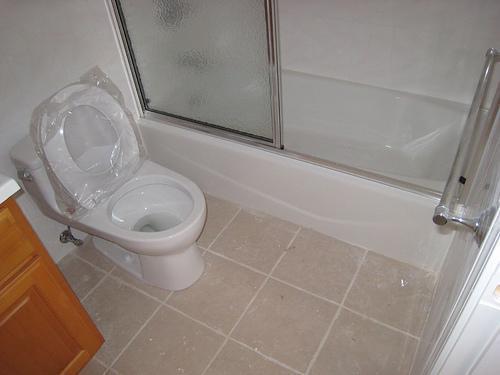How many bathtubs are there?
Give a very brief answer. 1. 